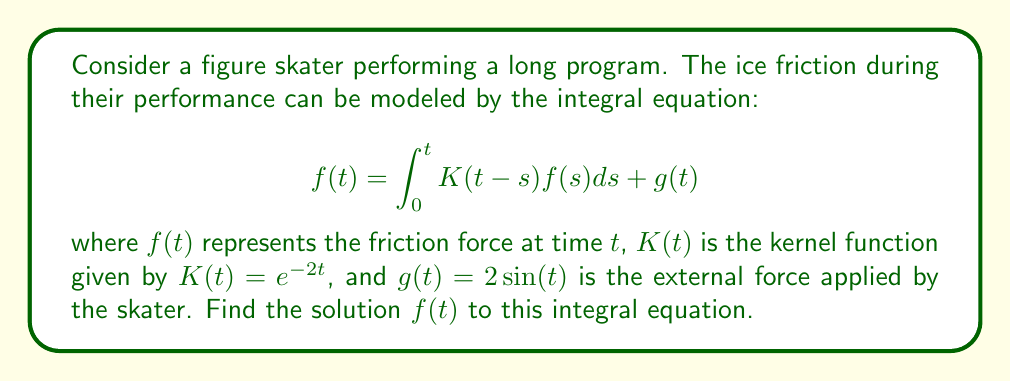Help me with this question. To solve this integral equation, we'll use the Laplace transform method:

1) Take the Laplace transform of both sides:
   $$\mathcal{L}\{f(t)\} = \mathcal{L}\{\int_0^t K(t-s)f(s)ds\} + \mathcal{L}\{g(t)\}$$

2) Use the convolution theorem:
   $$F(p) = K(p)F(p) + G(p)$$
   where $F(p)$, $K(p)$, and $G(p)$ are the Laplace transforms of $f(t)$, $K(t)$, and $g(t)$ respectively.

3) Calculate the Laplace transforms:
   $K(p) = \mathcal{L}\{e^{-2t}\} = \frac{1}{p+2}$
   $G(p) = \mathcal{L}\{2\sin(t)\} = \frac{2}{p^2+1}$

4) Substitute into the equation:
   $$F(p) = \frac{1}{p+2}F(p) + \frac{2}{p^2+1}$$

5) Solve for $F(p)$:
   $$F(p)(1 - \frac{1}{p+2}) = \frac{2}{p^2+1}$$
   $$F(p) = \frac{2}{p^2+1} \cdot \frac{p+2}{p+1}$$

6) Simplify:
   $$F(p) = \frac{2p+4}{(p^2+1)(p+1)}$$

7) Perform partial fraction decomposition:
   $$F(p) = \frac{A}{p+1} + \frac{Bp+C}{p^2+1}$$
   
   Solving for A, B, and C:
   $A = 2$, $B = 0$, $C = 2$

8) Take the inverse Laplace transform:
   $$f(t) = 2e^{-t} + 2\sin(t)$$

This is the solution to the integral equation.
Answer: $f(t) = 2e^{-t} + 2\sin(t)$ 